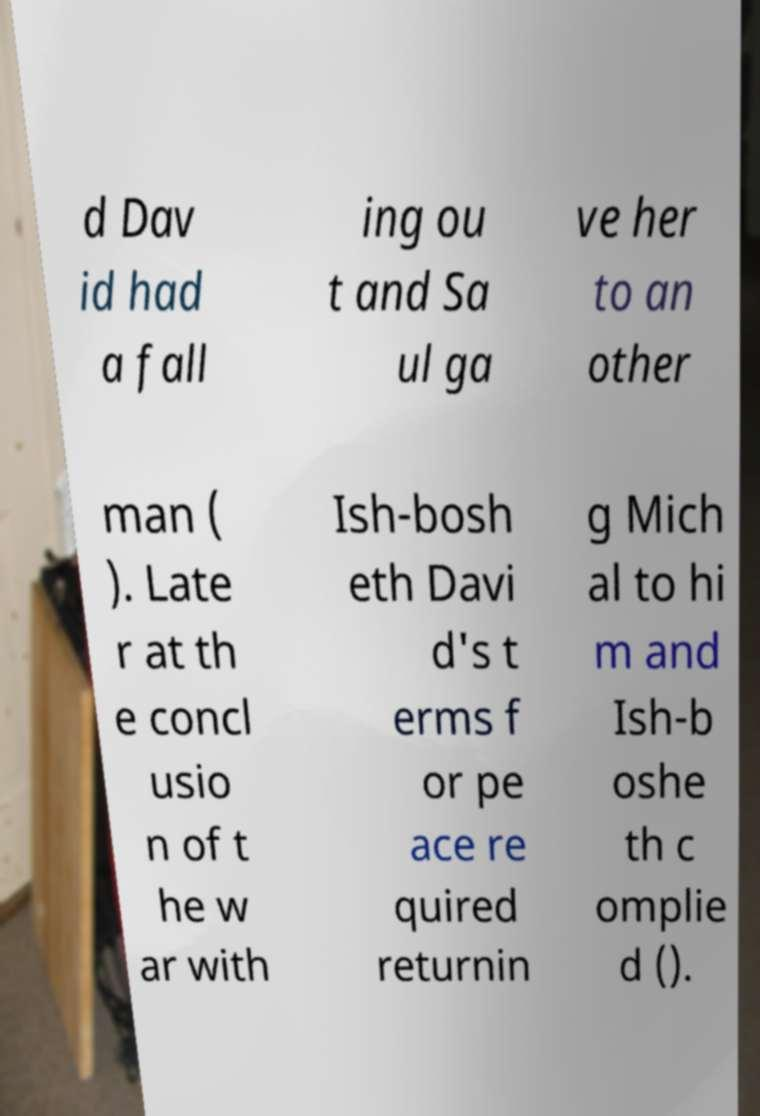Can you read and provide the text displayed in the image?This photo seems to have some interesting text. Can you extract and type it out for me? d Dav id had a fall ing ou t and Sa ul ga ve her to an other man ( ). Late r at th e concl usio n of t he w ar with Ish-bosh eth Davi d's t erms f or pe ace re quired returnin g Mich al to hi m and Ish-b oshe th c omplie d (). 